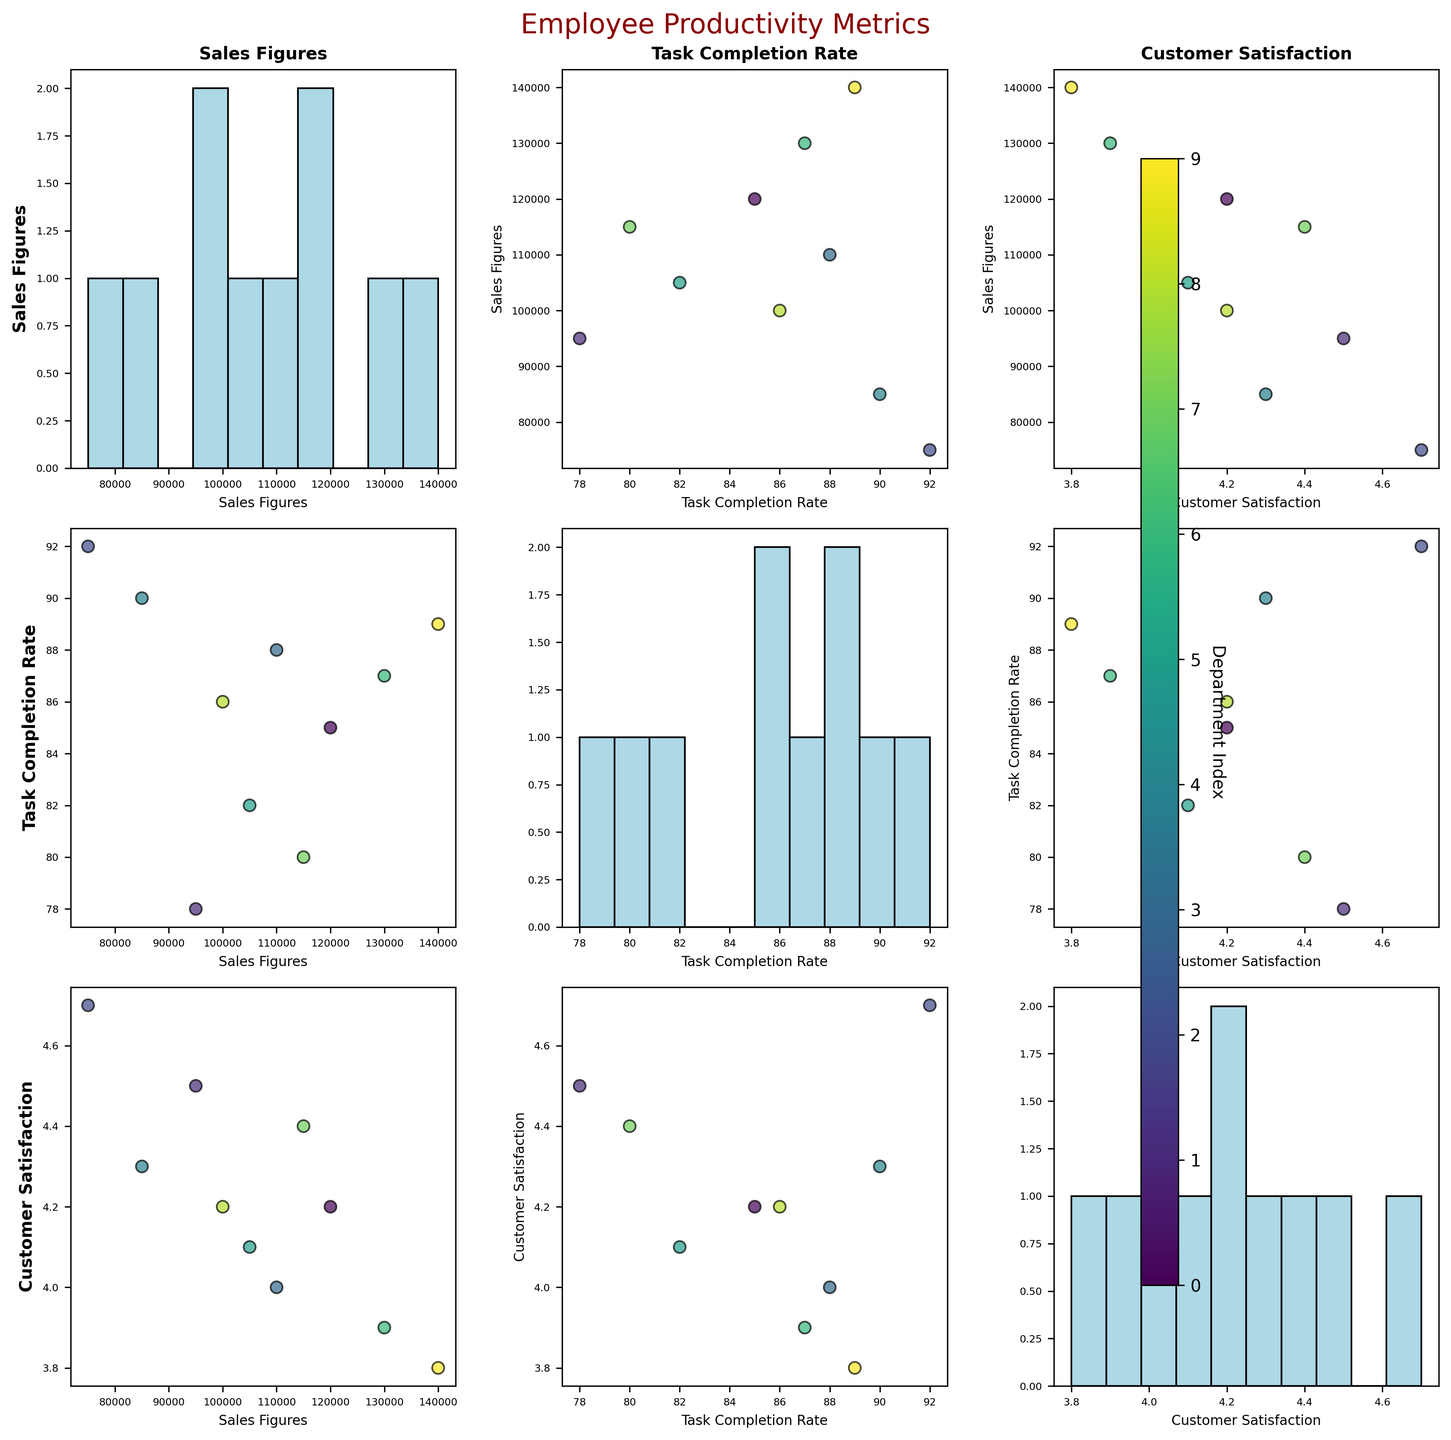What is the title of the figure? The title can be found at the top of the figure.
Answer: Employee Productivity Metrics What color represents the data points in the scatter plots? The data points are colored using a colormap, specifically in varying shades of green to purple (viridis).
Answer: Green to purple How many variables are plotted in the scatterplot matrix? Count the unique variables used in the scatterplot matrix.
Answer: 3 What is on the x-axis in the scatter plot of Sales Figures vs. Customer Satisfaction? Identify the variable plotted on the x-axis for the scatter plot of Sales Figures vs. Customer Satisfaction.
Answer: Customer Satisfaction Which department has the highest Sales Figures? Look at the scatter plot or histogram of Sales Figures to identify the department with the maximum value.
Answer: Legal What is the relationship between Sales Figures and Customer Satisfaction? Observe the scatter plot between Sales Figures and Customer Satisfaction to identify any trends, correlations, or patterns.
Answer: Generally, no clear trend Which pairs of variables show a positive correlation? Evaluate the scatter plots for each pair of variables and determine which pairs show a positive correlation.
Answer: Task Completion Rate and Customer Satisfaction What departments are at the top visually in the matrix? Identify the departments represented by points appearing higher on the plots within the scatterplot matrix. Use color index to confirm.
Answer: Sales, Finance, and Legal Is there any department that has consistently high performance across all three metrics? Examine the scatter plots and histograms to determine if any department consistently shows high values in Sales Figures, Task Completion Rate, and Customer Satisfaction.
Answer: No Which variable pair has the most spread in their data points? Observe the scatter plots and compare the spread of data points for each variable pair within the scatterplot matrix.
Answer: Sales Figures and Customer Satisfaction 